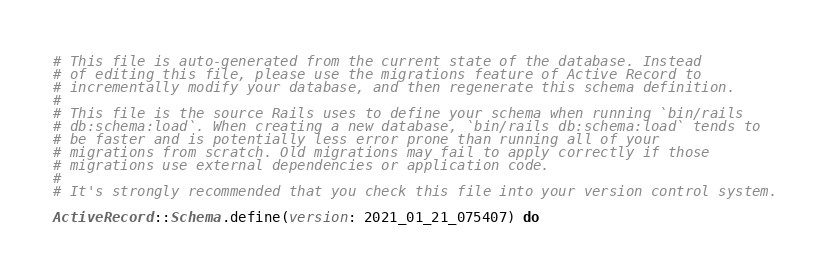<code> <loc_0><loc_0><loc_500><loc_500><_Ruby_># This file is auto-generated from the current state of the database. Instead
# of editing this file, please use the migrations feature of Active Record to
# incrementally modify your database, and then regenerate this schema definition.
#
# This file is the source Rails uses to define your schema when running `bin/rails
# db:schema:load`. When creating a new database, `bin/rails db:schema:load` tends to
# be faster and is potentially less error prone than running all of your
# migrations from scratch. Old migrations may fail to apply correctly if those
# migrations use external dependencies or application code.
#
# It's strongly recommended that you check this file into your version control system.

ActiveRecord::Schema.define(version: 2021_01_21_075407) do
</code> 